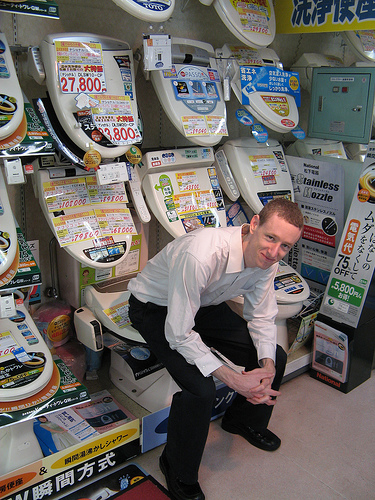On which side is the box? The box is placed on the left side of the scene, surrounded by various other bathroom fixtures. 